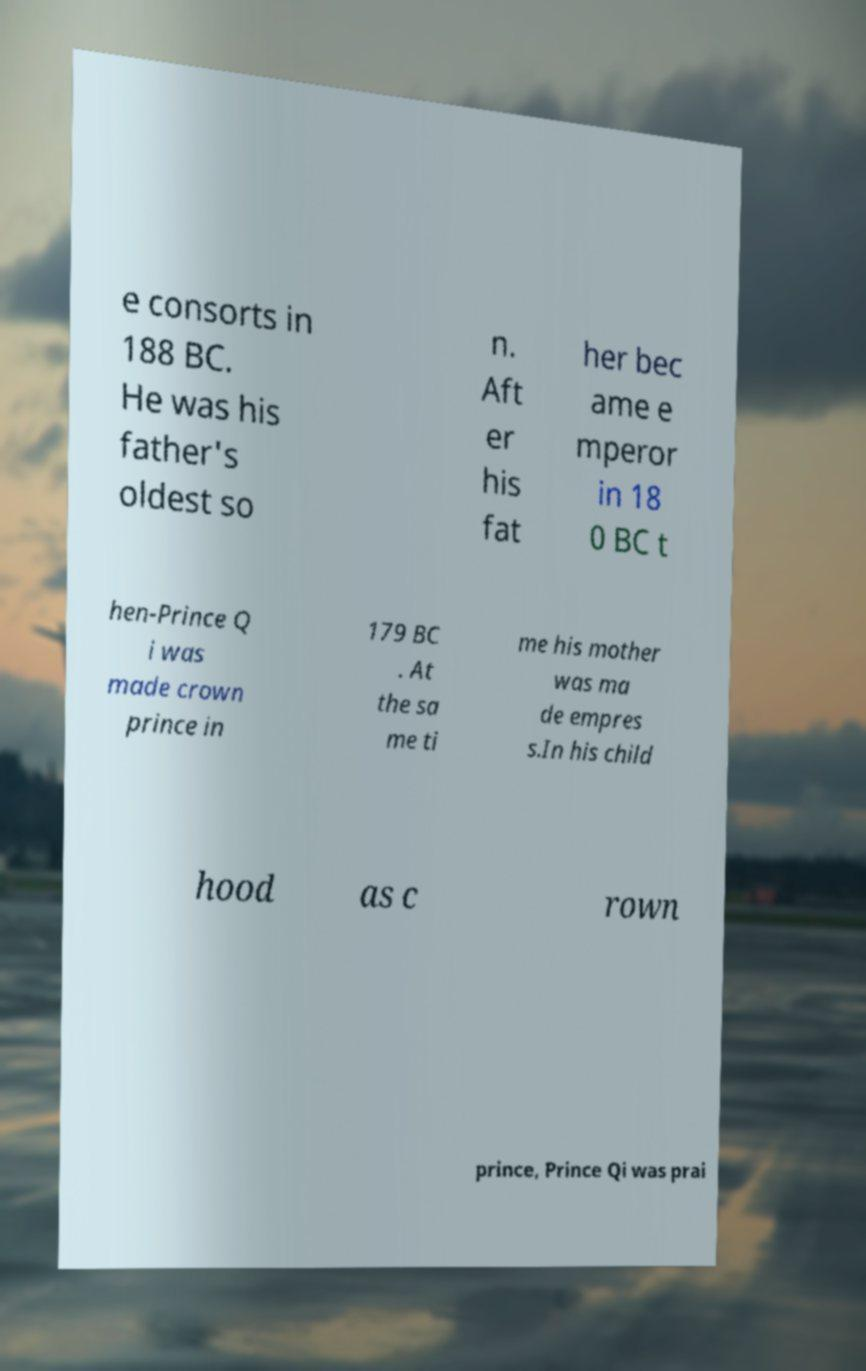What messages or text are displayed in this image? I need them in a readable, typed format. e consorts in 188 BC. He was his father's oldest so n. Aft er his fat her bec ame e mperor in 18 0 BC t hen-Prince Q i was made crown prince in 179 BC . At the sa me ti me his mother was ma de empres s.In his child hood as c rown prince, Prince Qi was prai 